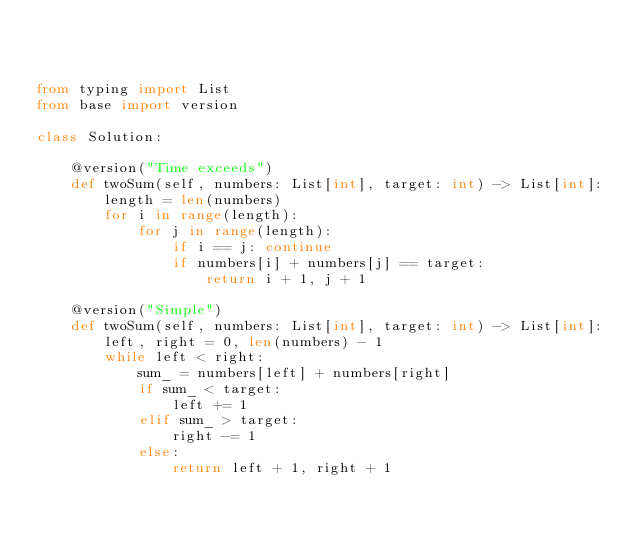Convert code to text. <code><loc_0><loc_0><loc_500><loc_500><_Python_>


from typing import List
from base import version

class Solution:

    @version("Time exceeds")
    def twoSum(self, numbers: List[int], target: int) -> List[int]:
        length = len(numbers)
        for i in range(length):
            for j in range(length):
                if i == j: continue
                if numbers[i] + numbers[j] == target:
                    return i + 1, j + 1
    
    @version("Simple")
    def twoSum(self, numbers: List[int], target: int) -> List[int]:
        left, right = 0, len(numbers) - 1
        while left < right:
            sum_ = numbers[left] + numbers[right]
            if sum_ < target:
                left += 1
            elif sum_ > target:
                right -= 1
            else:
                return left + 1, right + 1









</code> 